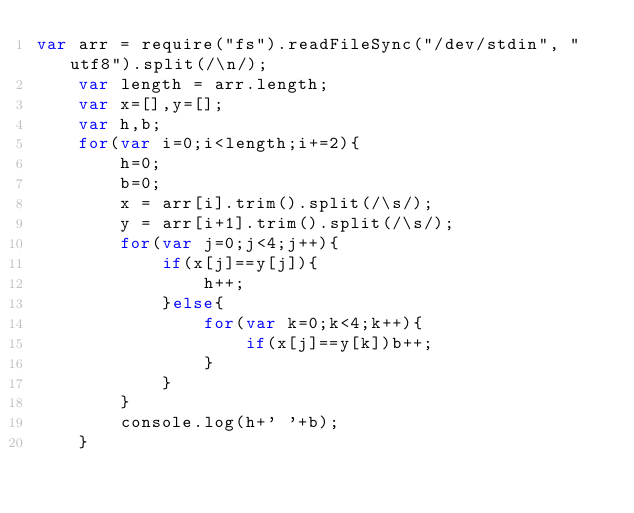Convert code to text. <code><loc_0><loc_0><loc_500><loc_500><_JavaScript_>var arr = require("fs").readFileSync("/dev/stdin", "utf8").split(/\n/);
	var length = arr.length;
	var x=[],y=[];
	var h,b;
	for(var i=0;i<length;i+=2){
		h=0;
		b=0;
		x = arr[i].trim().split(/\s/);
		y = arr[i+1].trim().split(/\s/);
		for(var j=0;j<4;j++){
			if(x[j]==y[j]){
				h++;
			}else{
				for(var k=0;k<4;k++){
					if(x[j]==y[k])b++;
				}
			}
		}
		console.log(h+' '+b);
	}</code> 